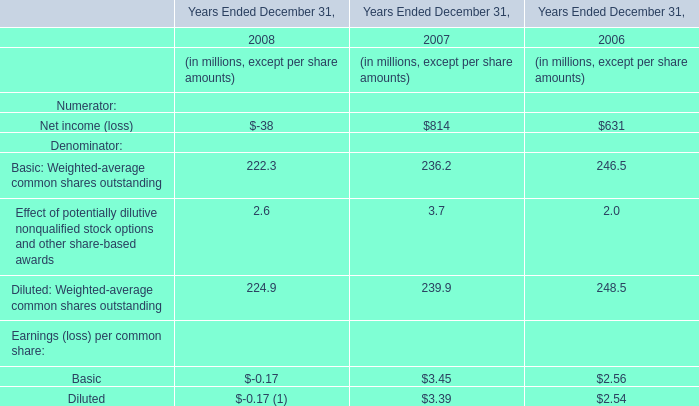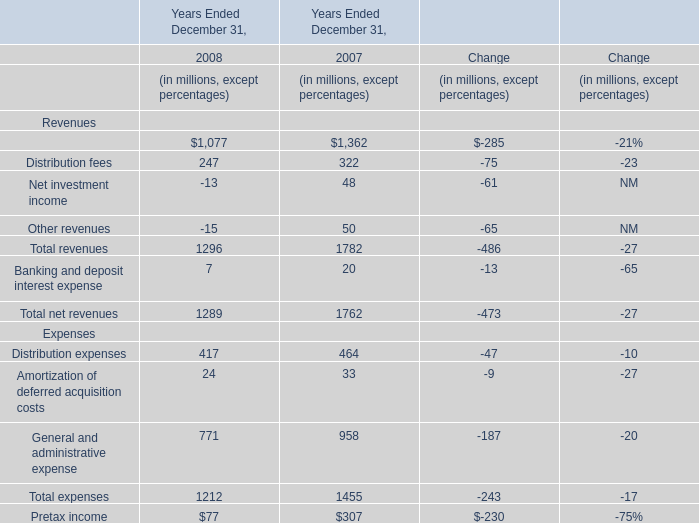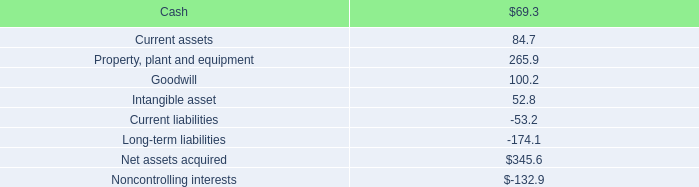what was the implied total value in millions of the brazilian beverage packaging joint venture , latapack-ball , in august 2010? 
Computations: (46.2 / (10.1 / 100))
Answer: 457.42574. 